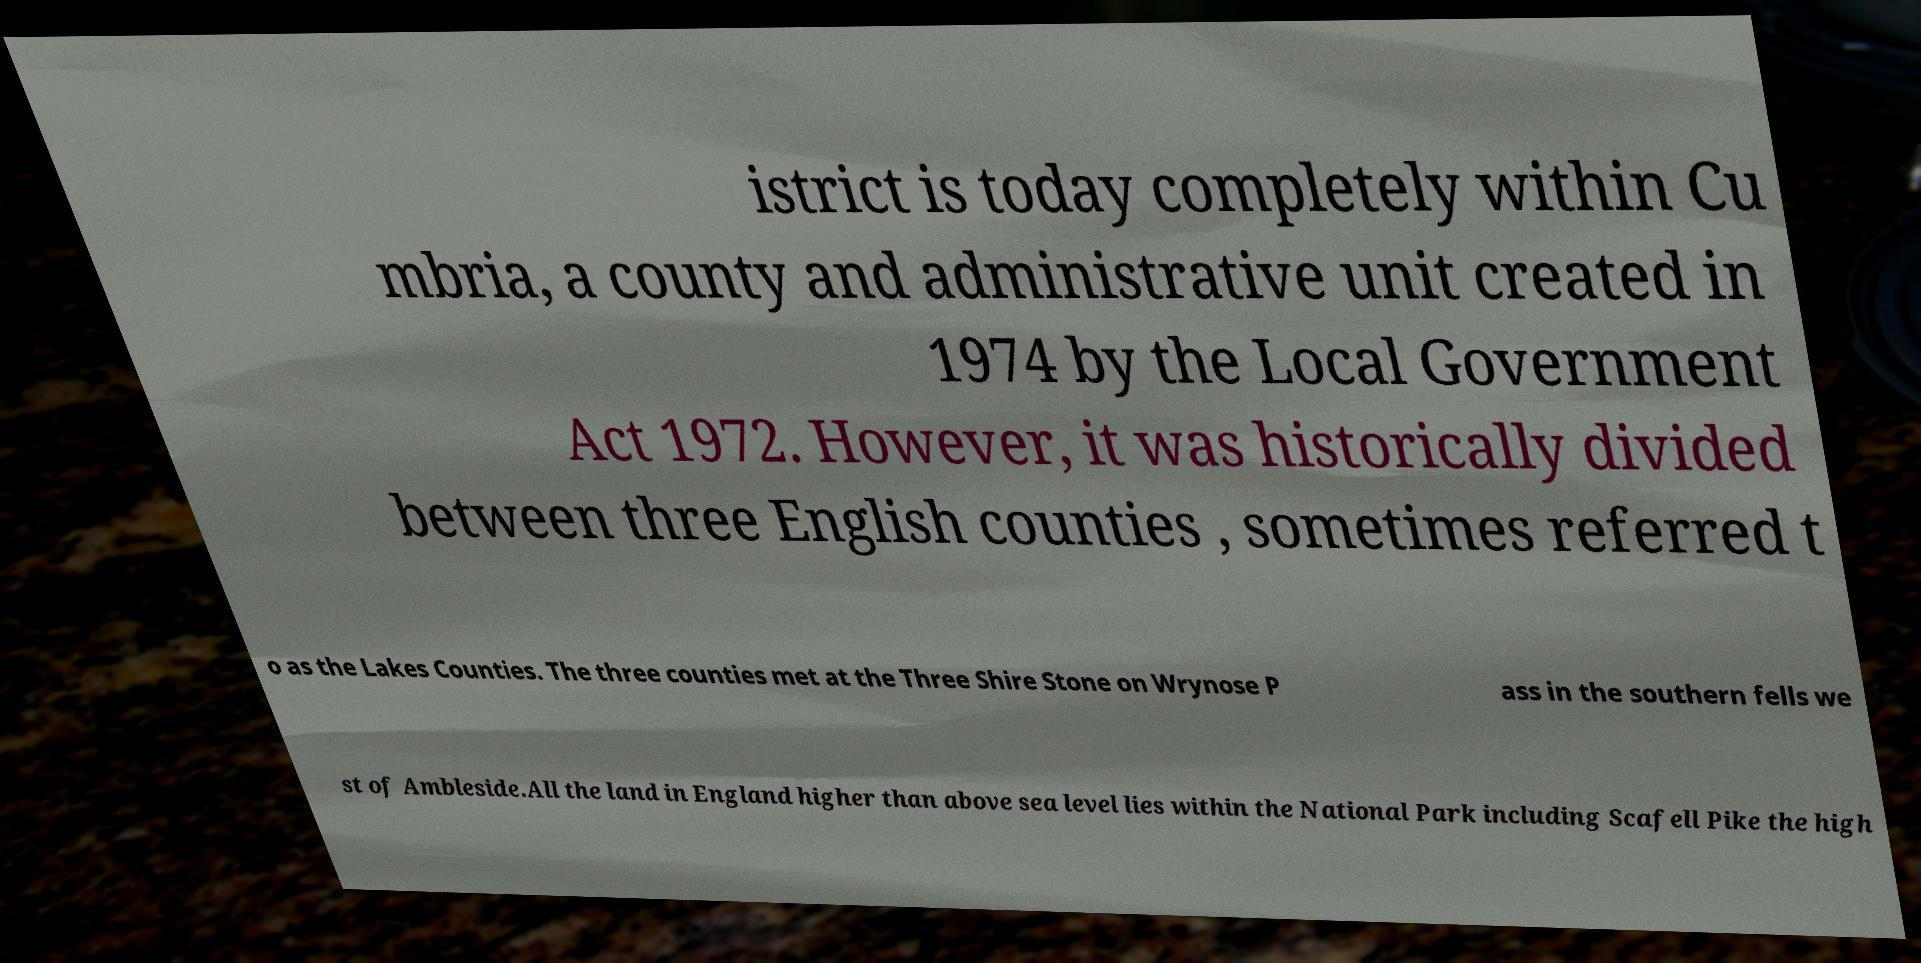What messages or text are displayed in this image? I need them in a readable, typed format. istrict is today completely within Cu mbria, a county and administrative unit created in 1974 by the Local Government Act 1972. However, it was historically divided between three English counties , sometimes referred t o as the Lakes Counties. The three counties met at the Three Shire Stone on Wrynose P ass in the southern fells we st of Ambleside.All the land in England higher than above sea level lies within the National Park including Scafell Pike the high 